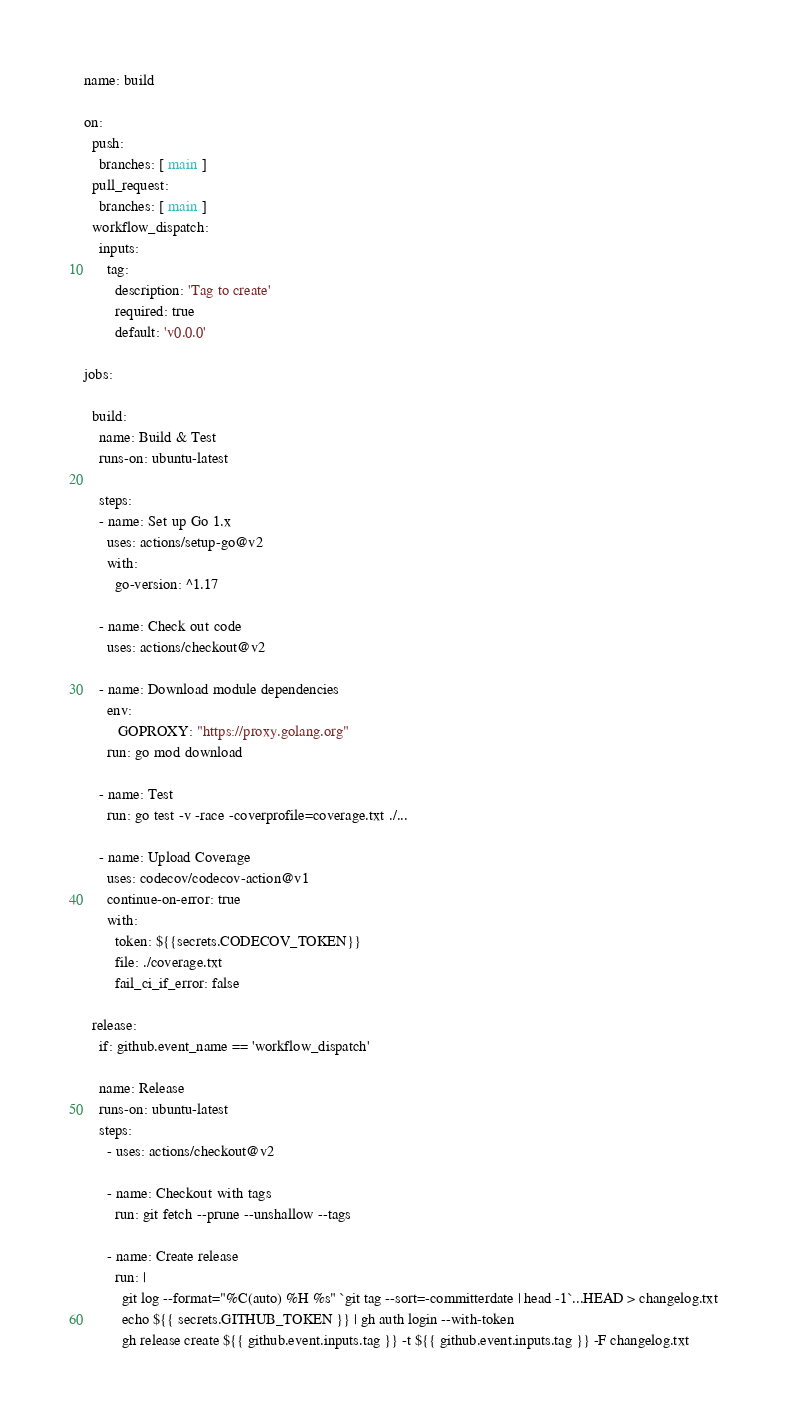<code> <loc_0><loc_0><loc_500><loc_500><_YAML_>name: build

on:
  push:
    branches: [ main ]
  pull_request:
    branches: [ main ]
  workflow_dispatch:
    inputs:
      tag:
        description: 'Tag to create'
        required: true
        default: 'v0.0.0'

jobs:

  build:
    name: Build & Test
    runs-on: ubuntu-latest

    steps:
    - name: Set up Go 1.x
      uses: actions/setup-go@v2
      with:
        go-version: ^1.17

    - name: Check out code
      uses: actions/checkout@v2

    - name: Download module dependencies
      env: 
         GOPROXY: "https://proxy.golang.org"
      run: go mod download

    - name: Test
      run: go test -v -race -coverprofile=coverage.txt ./...

    - name: Upload Coverage
      uses: codecov/codecov-action@v1
      continue-on-error: true
      with:
        token: ${{secrets.CODECOV_TOKEN}}
        file: ./coverage.txt
        fail_ci_if_error: false

  release:
    if: github.event_name == 'workflow_dispatch'

    name: Release
    runs-on: ubuntu-latest
    steps:
      - uses: actions/checkout@v2

      - name: Checkout with tags
        run: git fetch --prune --unshallow --tags

      - name: Create release
        run: |
          git log --format="%C(auto) %H %s" `git tag --sort=-committerdate | head -1`...HEAD > changelog.txt
          echo ${{ secrets.GITHUB_TOKEN }} | gh auth login --with-token
          gh release create ${{ github.event.inputs.tag }} -t ${{ github.event.inputs.tag }} -F changelog.txt
</code> 